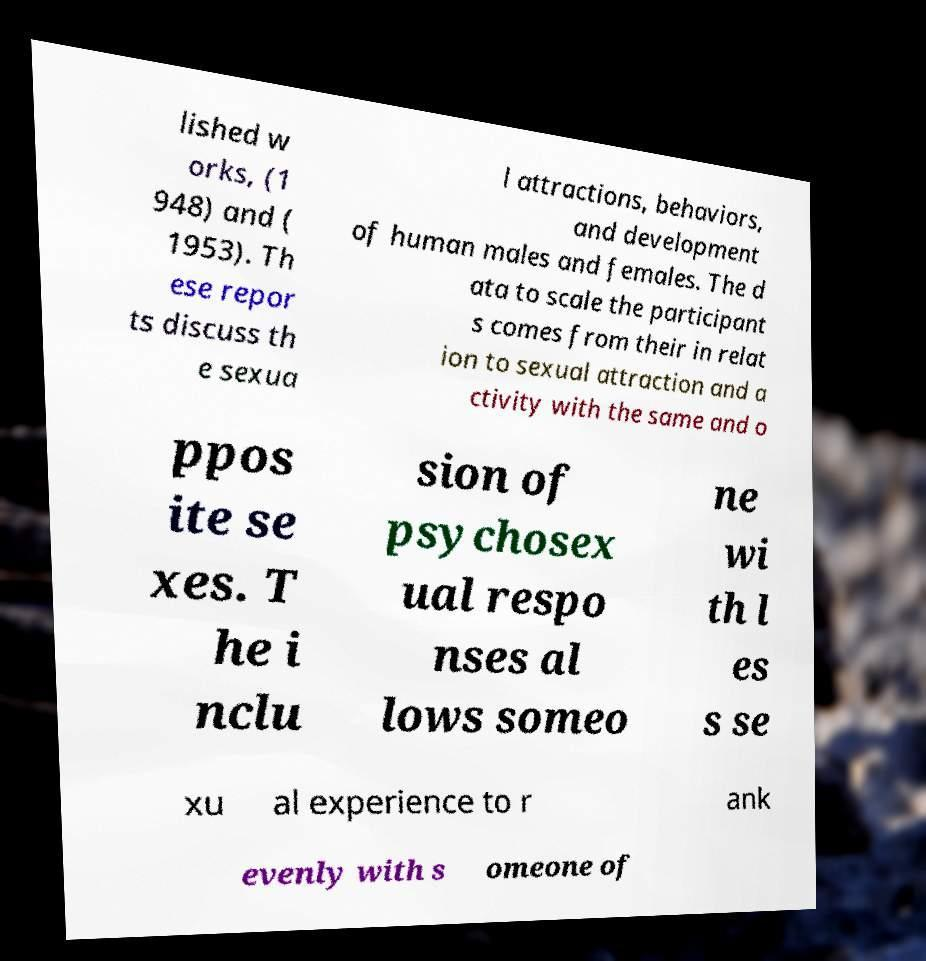Could you assist in decoding the text presented in this image and type it out clearly? lished w orks, (1 948) and ( 1953). Th ese repor ts discuss th e sexua l attractions, behaviors, and development of human males and females. The d ata to scale the participant s comes from their in relat ion to sexual attraction and a ctivity with the same and o ppos ite se xes. T he i nclu sion of psychosex ual respo nses al lows someo ne wi th l es s se xu al experience to r ank evenly with s omeone of 